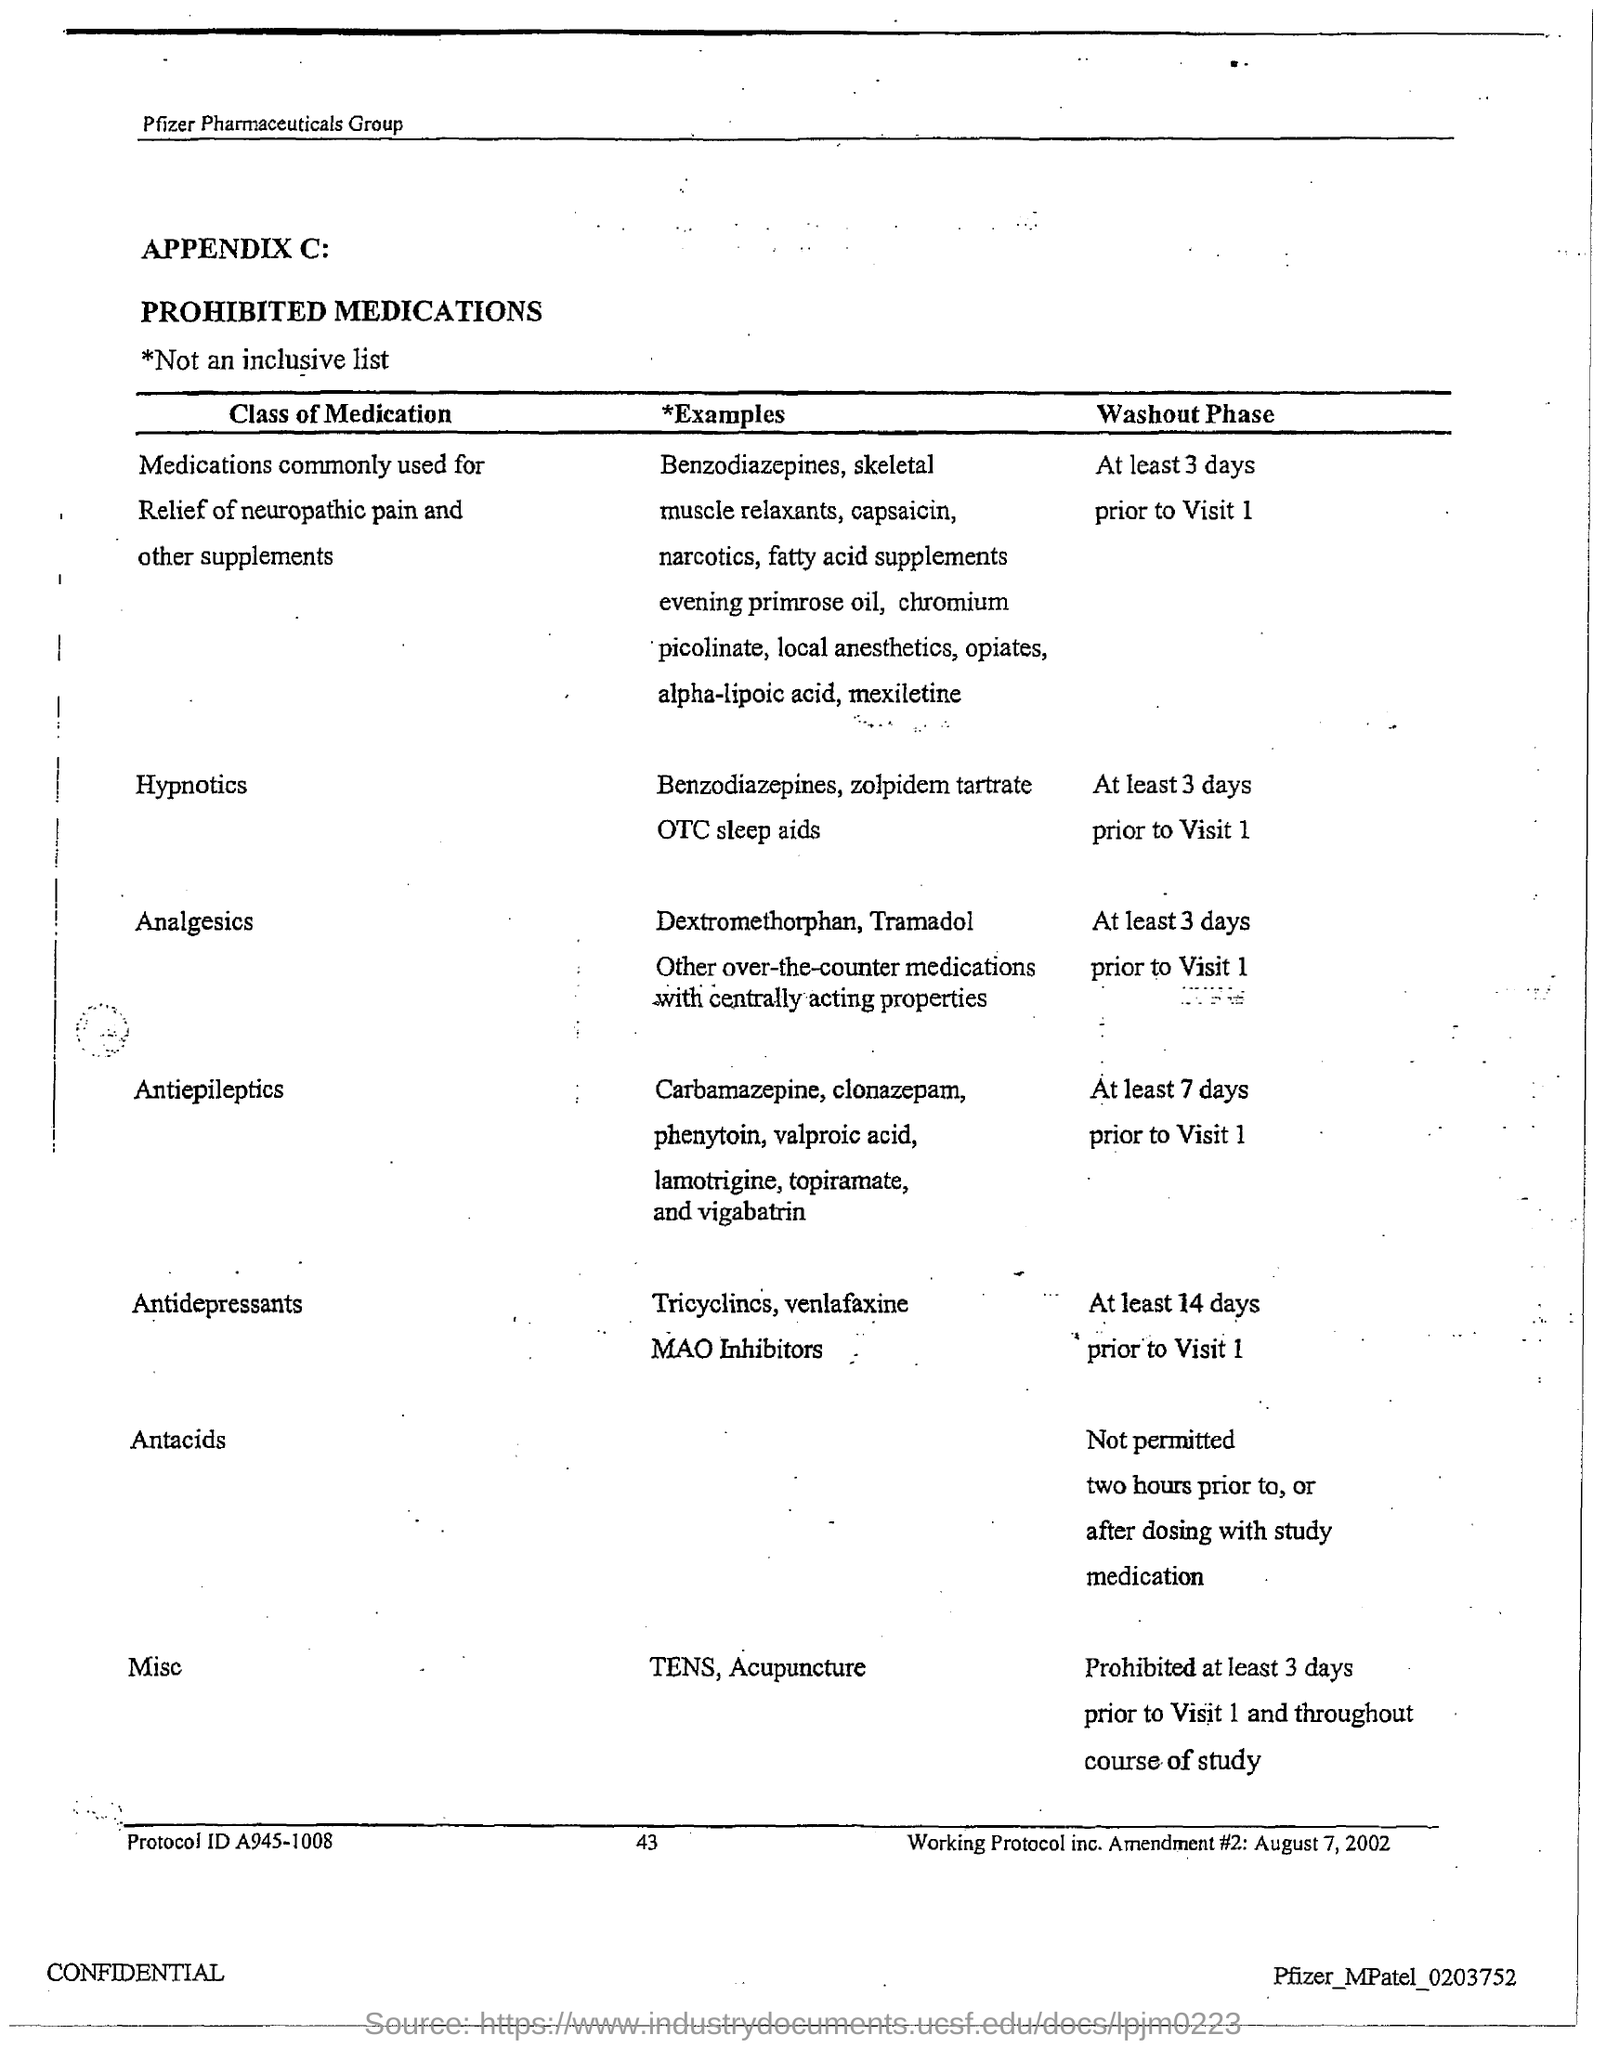Identify some key points in this picture. The protocol ID given in the document is A945-1008. The page number mentioned in this document is 43. 